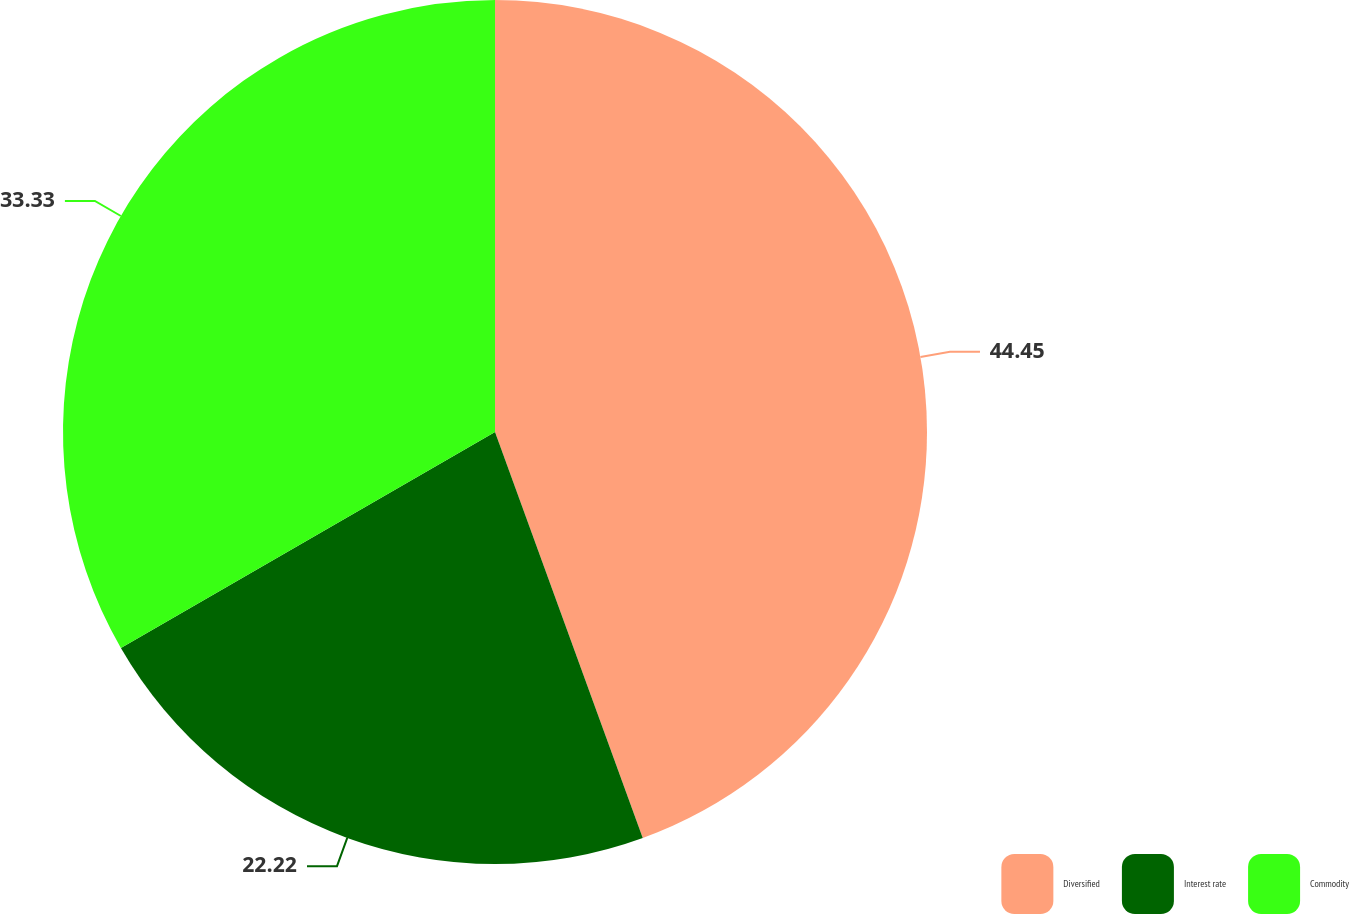Convert chart. <chart><loc_0><loc_0><loc_500><loc_500><pie_chart><fcel>Diversified<fcel>Interest rate<fcel>Commodity<nl><fcel>44.44%<fcel>22.22%<fcel>33.33%<nl></chart> 